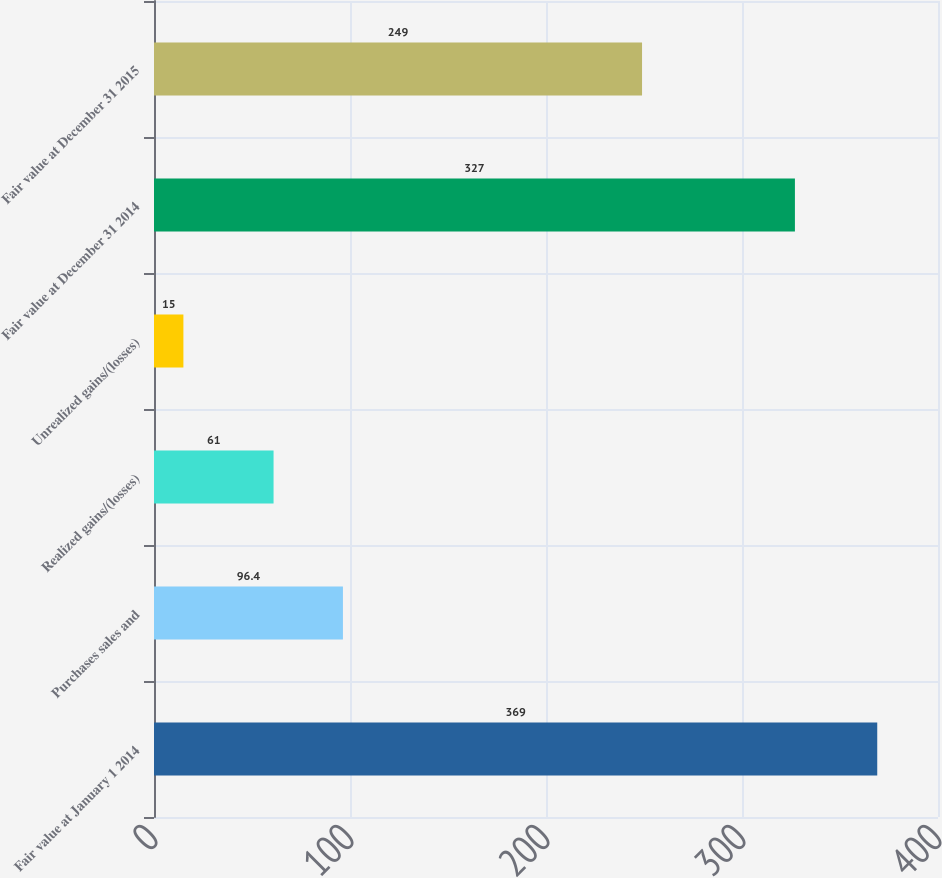Convert chart. <chart><loc_0><loc_0><loc_500><loc_500><bar_chart><fcel>Fair value at January 1 2014<fcel>Purchases sales and<fcel>Realized gains/(losses)<fcel>Unrealized gains/(losses)<fcel>Fair value at December 31 2014<fcel>Fair value at December 31 2015<nl><fcel>369<fcel>96.4<fcel>61<fcel>15<fcel>327<fcel>249<nl></chart> 